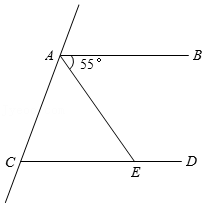Outline your observations regarding the picture. The image features a geometric diagram with two parallel lines, labeled AB and CD. These lines are intersected by a transversal line, creating different angles at the points of intersection. Point E is where this transversal intersects line CD. Additionally, an angle of 55 degrees is marked at point A, where the transversal line meets line AB. 